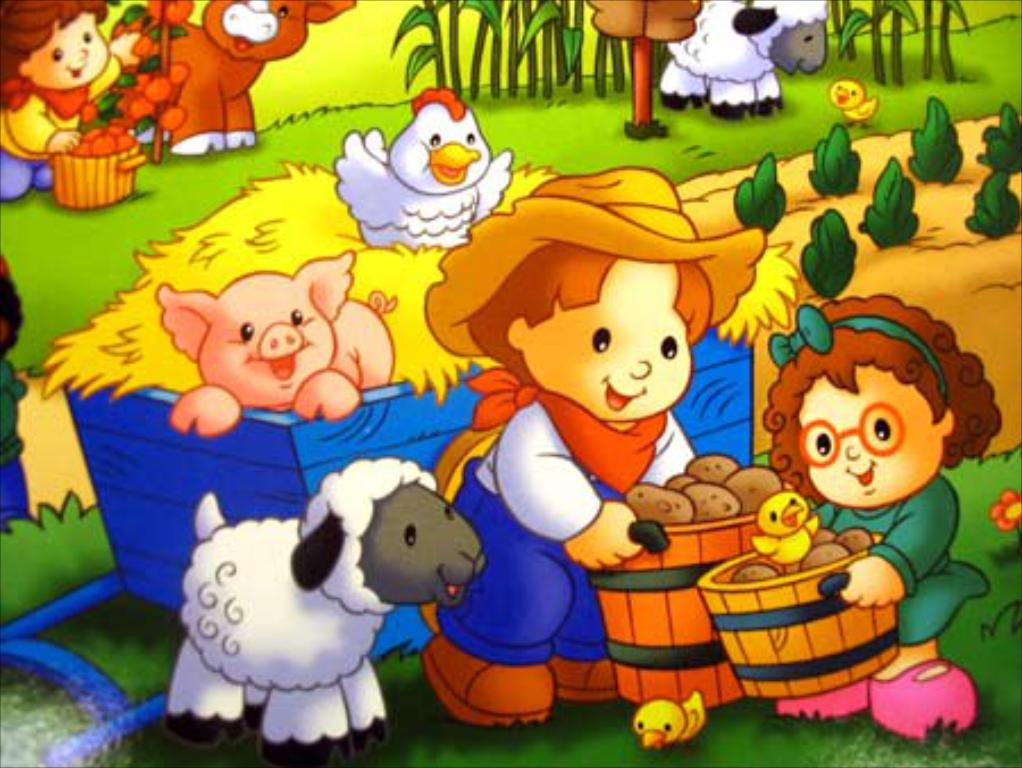What type of images are present in the picture? There are cartoon images in the picture. How many times does the character pull the lip of the cast in the image? There is no character pulling a lip or wearing a cast in the image, as it only contains cartoon images. 